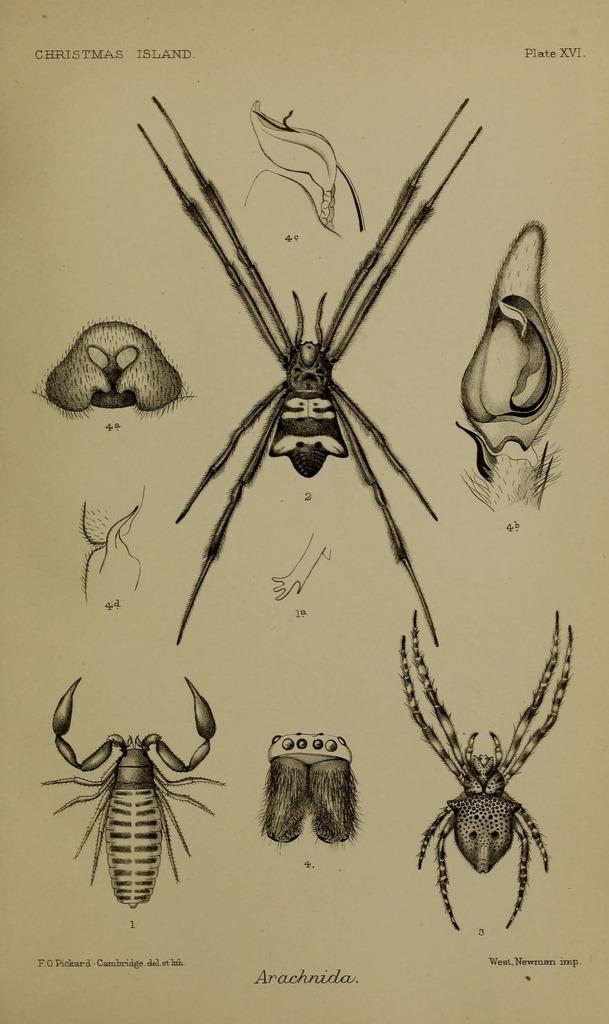What is the main subject of the image? The main subject of the image is a picture of insects. What is the picture of insects printed on? The picture of insects is on a paper. What type of cave can be seen in the background of the image? There is no cave present in the image; it features a picture of insects on a paper. 